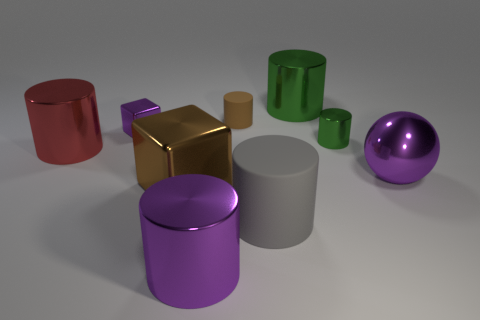Subtract 2 cylinders. How many cylinders are left? 4 Subtract all tiny brown rubber cylinders. How many cylinders are left? 5 Subtract all purple cylinders. How many cylinders are left? 5 Add 1 large brown rubber balls. How many objects exist? 10 Subtract all brown cylinders. Subtract all brown blocks. How many cylinders are left? 5 Subtract all blocks. How many objects are left? 7 Subtract all large blue cylinders. Subtract all red metal objects. How many objects are left? 8 Add 6 large brown objects. How many large brown objects are left? 7 Add 9 brown metal blocks. How many brown metal blocks exist? 10 Subtract 0 cyan balls. How many objects are left? 9 